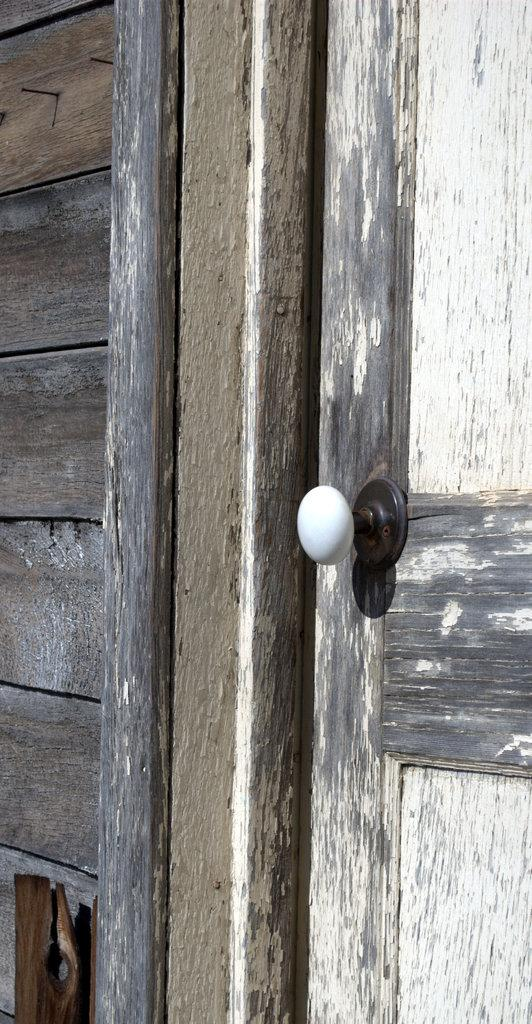What type of house is in the image? There is a wooden house in the image. What feature does the wooden house have? The wooden house has a door. What part of the door allows it to be opened or closed? The door has a handle. How many cents can be seen on the door handle in the image? There are no cents present on the door handle in the image. 